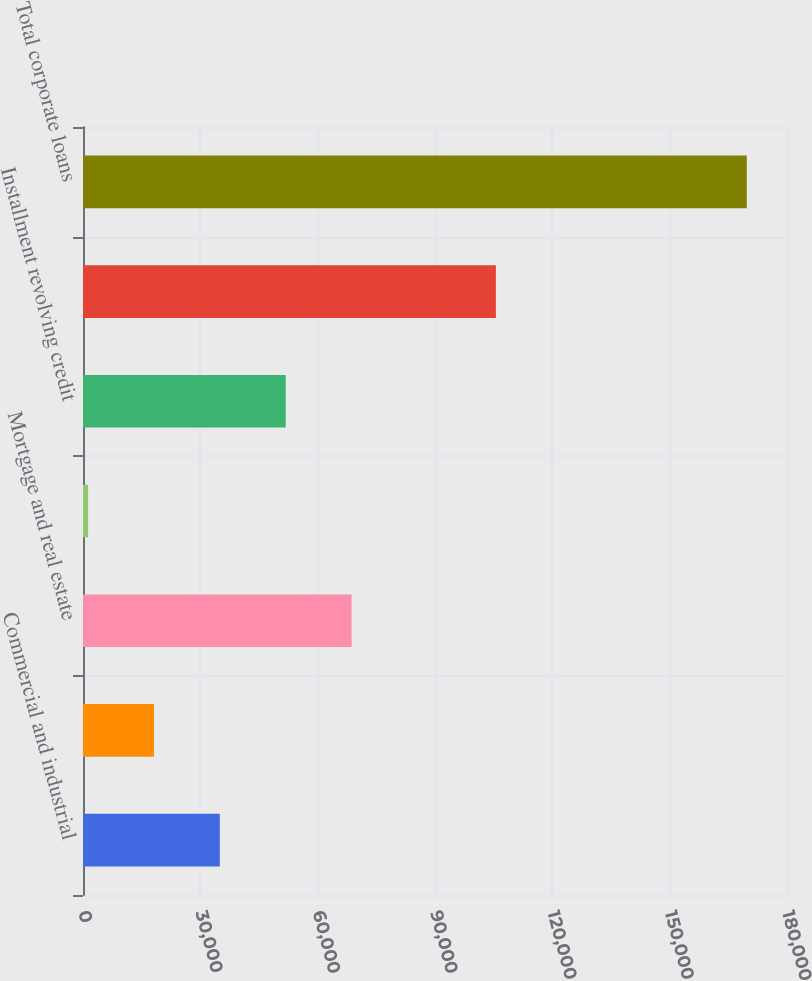Convert chart. <chart><loc_0><loc_0><loc_500><loc_500><bar_chart><fcel>Commercial and industrial<fcel>Financial institutions<fcel>Mortgage and real estate<fcel>Lease financing<fcel>Installment revolving credit<fcel>In offices outside the US<fcel>Total corporate loans<nl><fcel>34981.8<fcel>18139.4<fcel>68666.6<fcel>1297<fcel>51824.2<fcel>105566<fcel>169721<nl></chart> 